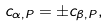Convert formula to latex. <formula><loc_0><loc_0><loc_500><loc_500>c _ { \alpha , P } = \pm c _ { \beta , P } ,</formula> 